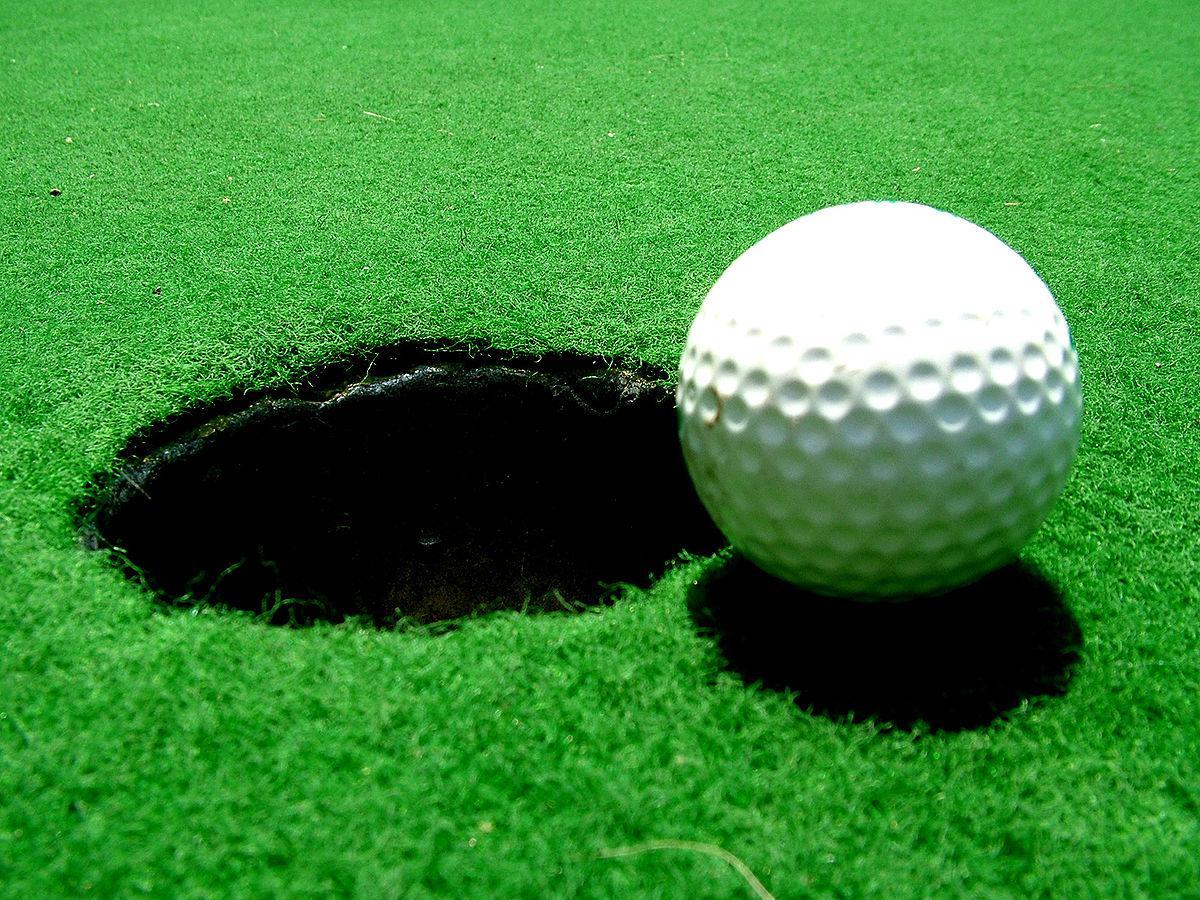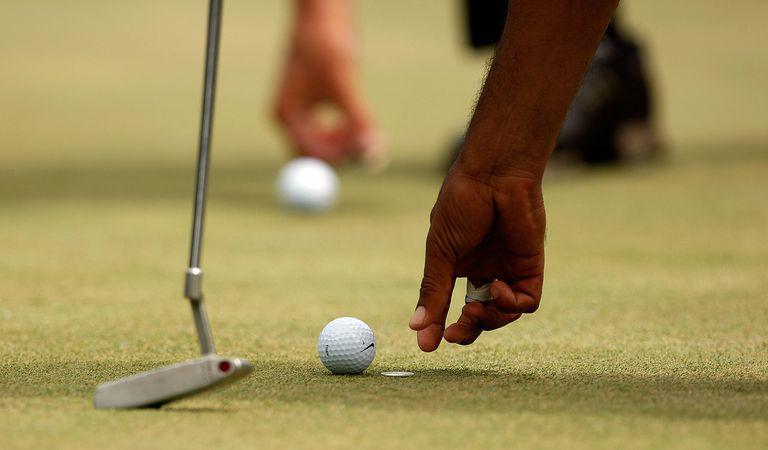The first image is the image on the left, the second image is the image on the right. Evaluate the accuracy of this statement regarding the images: "An image shows multiple golf balls near a hole with a pole in it.". Is it true? Answer yes or no. No. The first image is the image on the left, the second image is the image on the right. Considering the images on both sides, is "In one of the images there are at least two golf balls positioned near a hole with a golf flagpole inserted in it." valid? Answer yes or no. No. 